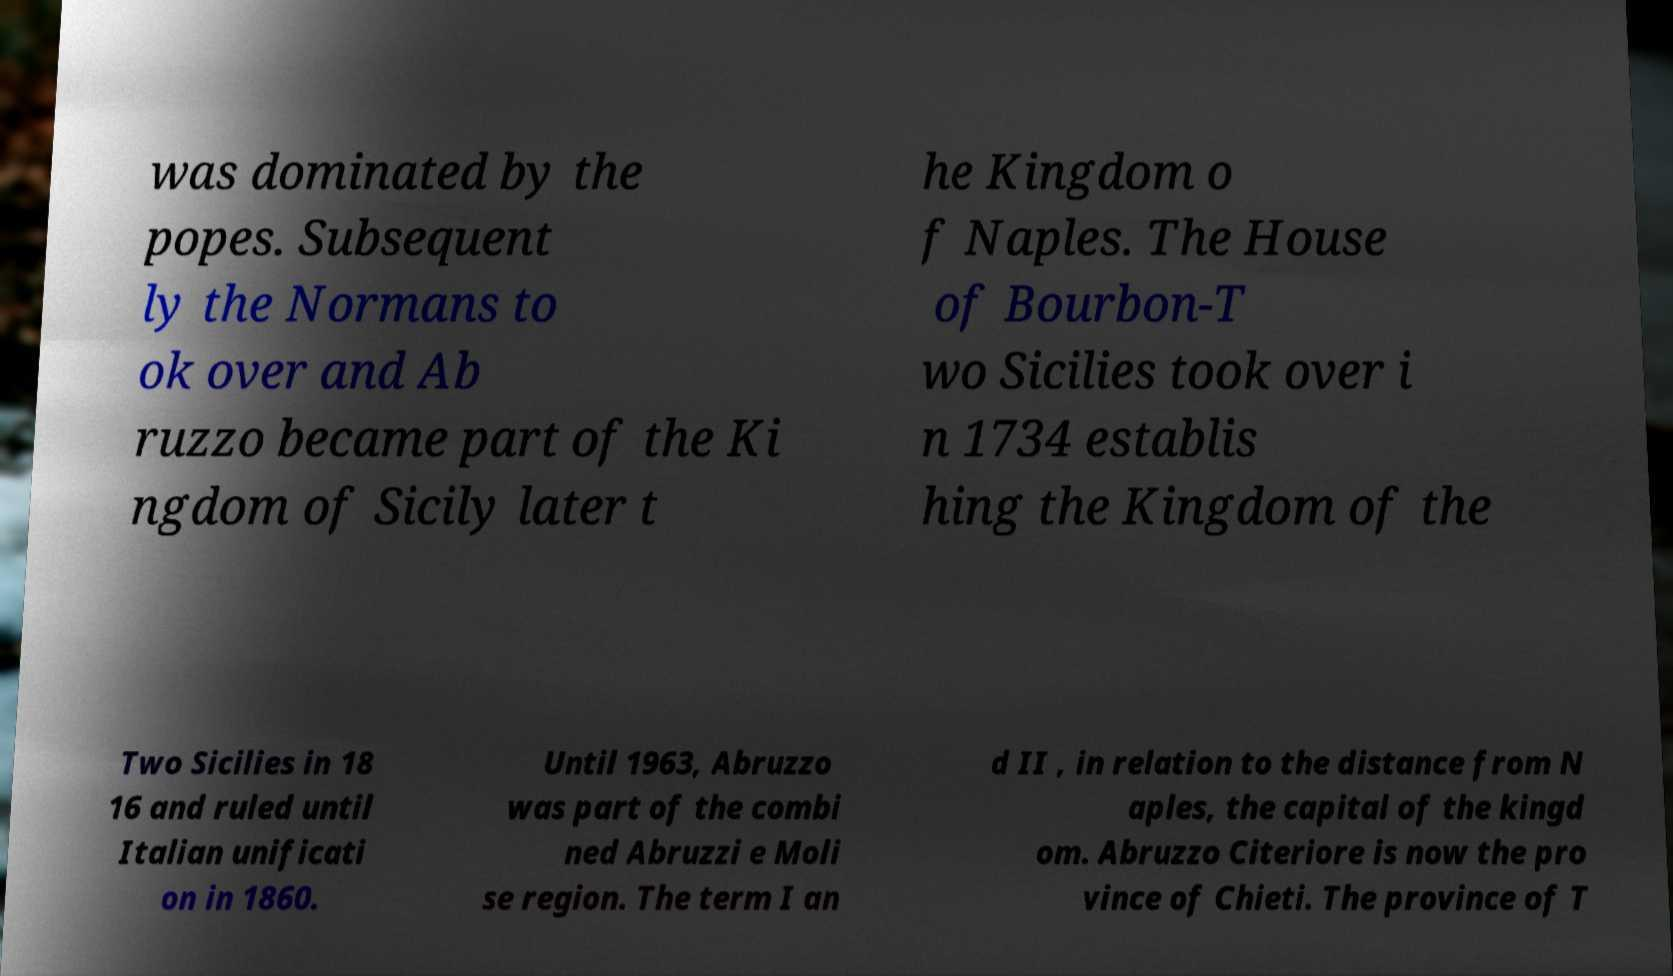Can you accurately transcribe the text from the provided image for me? was dominated by the popes. Subsequent ly the Normans to ok over and Ab ruzzo became part of the Ki ngdom of Sicily later t he Kingdom o f Naples. The House of Bourbon-T wo Sicilies took over i n 1734 establis hing the Kingdom of the Two Sicilies in 18 16 and ruled until Italian unificati on in 1860. Until 1963, Abruzzo was part of the combi ned Abruzzi e Moli se region. The term I an d II , in relation to the distance from N aples, the capital of the kingd om. Abruzzo Citeriore is now the pro vince of Chieti. The province of T 